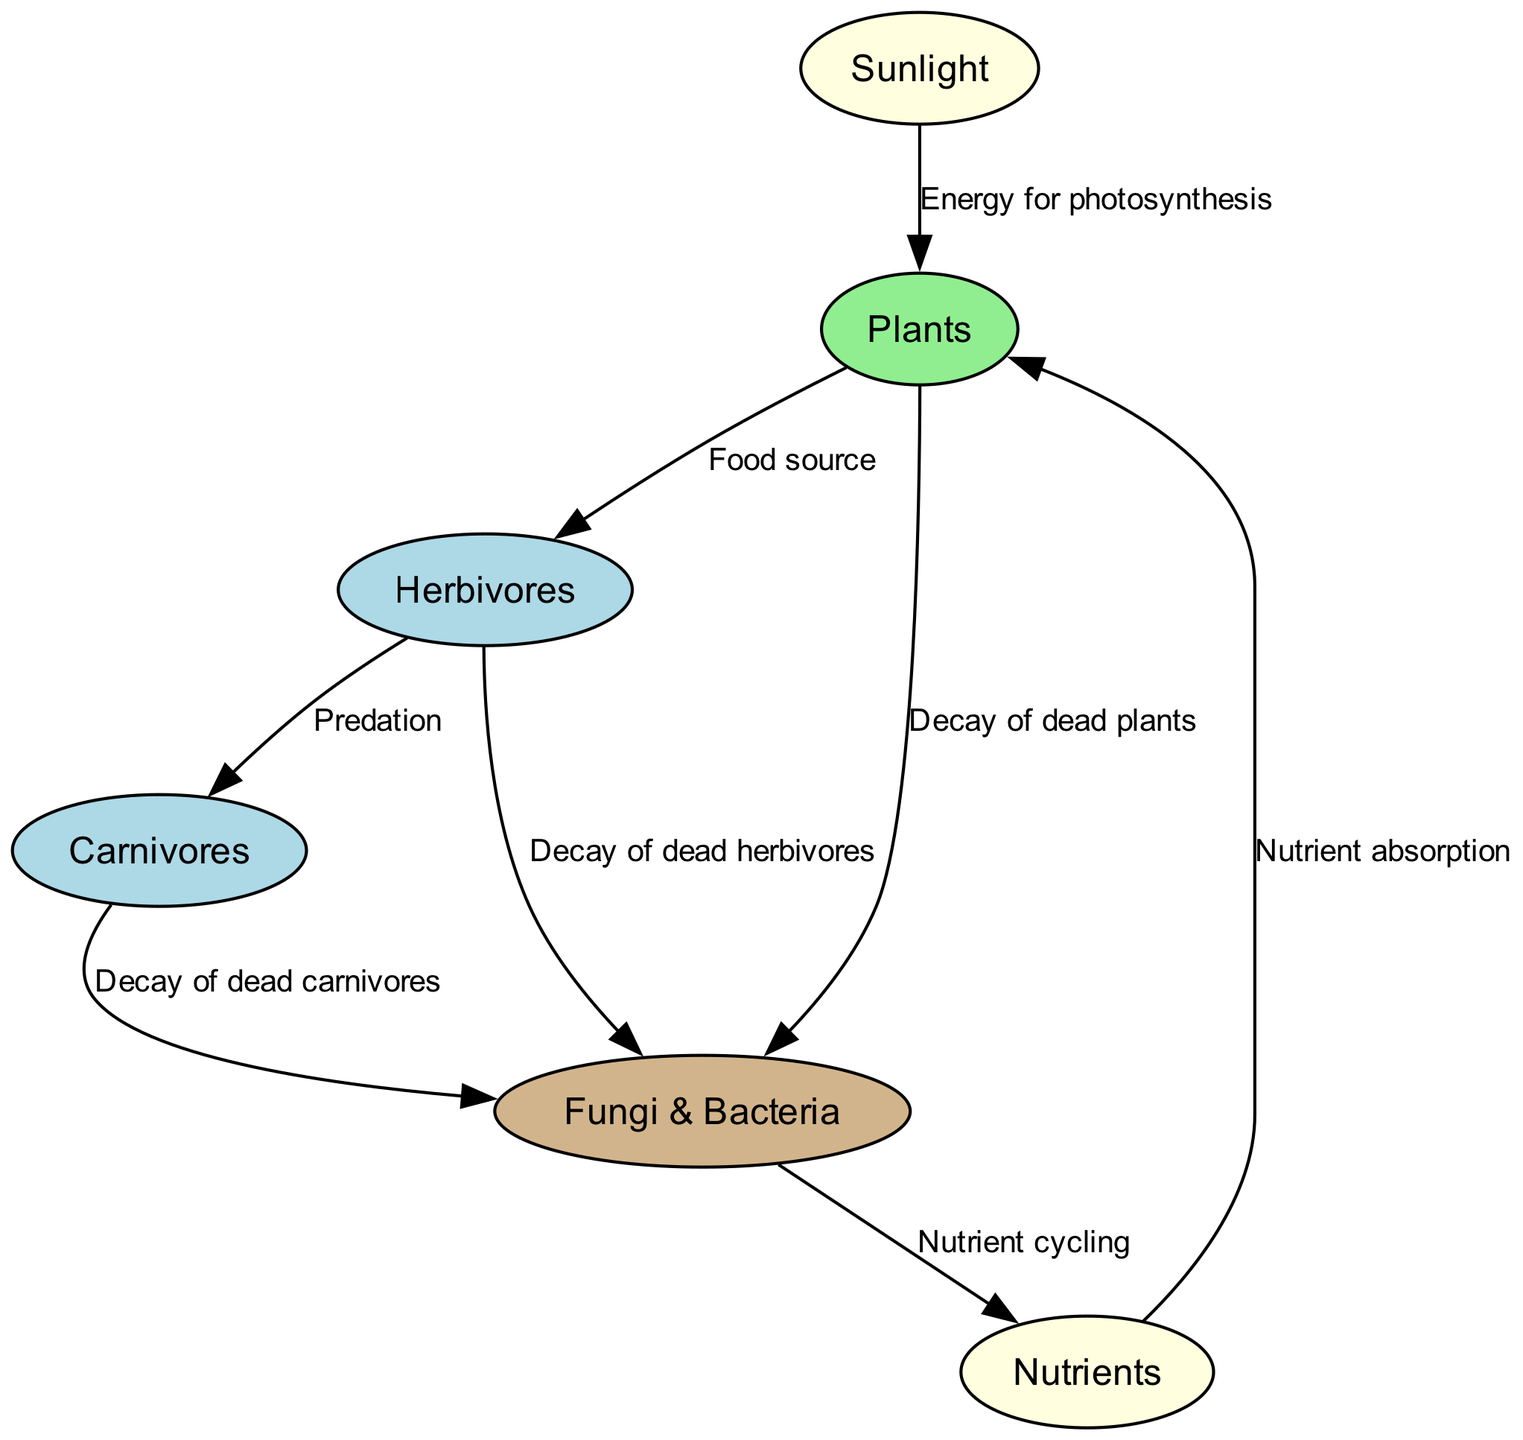What is the total number of nodes in the diagram? The diagram consists of nodes representing different components of the food chain. Counting the nodes listed, we have six nodes: Sunlight, Producers, Primary Consumers, Secondary Consumers, Decomposers, and Nutrients.
Answer: 6 What is the relationship label between Sunlight and Producers? The edge direct from Sunlight to Producers has the label "Energy for photosynthesis," indicating how sunlight contributes energy to plants.
Answer: Energy for photosynthesis Which category do Herbivores belong to in the diagram? Herbivores are represented as Primary Consumers in the diagram, showcasing their role in the food chain after Producers.
Answer: Primary Consumers How many edges are present in the diagram? By counting the connections (edges) listed between the nodes, there are eight edges, each representing interactions among the components of the food chain.
Answer: 8 What do Decomposers contribute to in the nutrient cycle? Decomposers, through the relationship labeled "Nutrient cycling," help break down dead organic matter, returning nutrients to the ecosystem.
Answer: Nutrients What is the flow sequence from Producers to Secondary Consumers? The flow from Producers leads to Primary Consumers (Herbivores), which then leads to Secondary Consumers (Carnivores). This sequence shows the transfer of energy and nutrients through the food chain.
Answer: Producers -> Primary Consumers -> Secondary Consumers What connects Fungi & Bacteria to Nutrients? The edge from Decomposers (Fungi & Bacteria) to Nutrients is labeled "Nutrient cycling," indicating that decomposers recycle nutrients back into the ecosystem.
Answer: Nutrient cycling Which node serves as the energy source for photosynthesis? The node indicating the energy required for photosynthesis is Sunlight, which is essential for Producers to convert energy into a usable form.
Answer: Sunlight What type of organisms are included in the Decomposers category? The Decomposers category includes Fungi and Bacteria, which play a vital role in breaking down organic matter in the ecosystem.
Answer: Fungi & Bacteria 